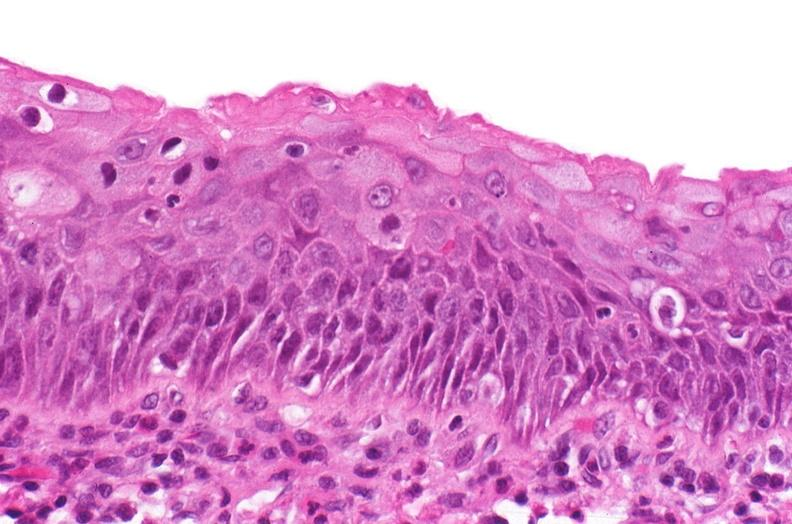s papillary astrocytoma present?
Answer the question using a single word or phrase. No 